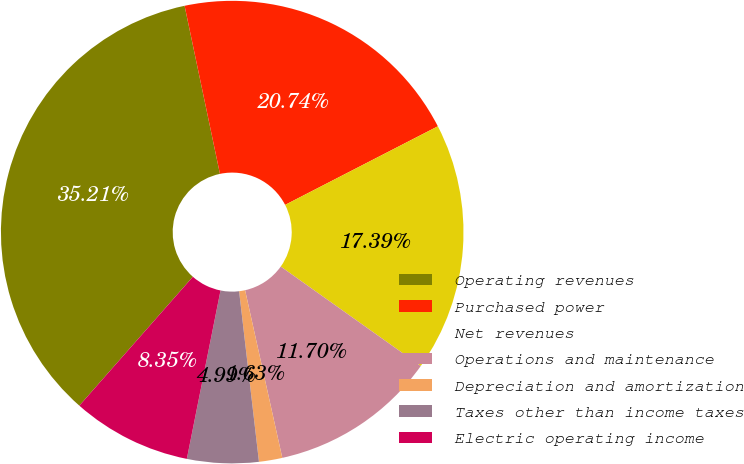<chart> <loc_0><loc_0><loc_500><loc_500><pie_chart><fcel>Operating revenues<fcel>Purchased power<fcel>Net revenues<fcel>Operations and maintenance<fcel>Depreciation and amortization<fcel>Taxes other than income taxes<fcel>Electric operating income<nl><fcel>35.21%<fcel>20.74%<fcel>17.39%<fcel>11.7%<fcel>1.63%<fcel>4.99%<fcel>8.35%<nl></chart> 